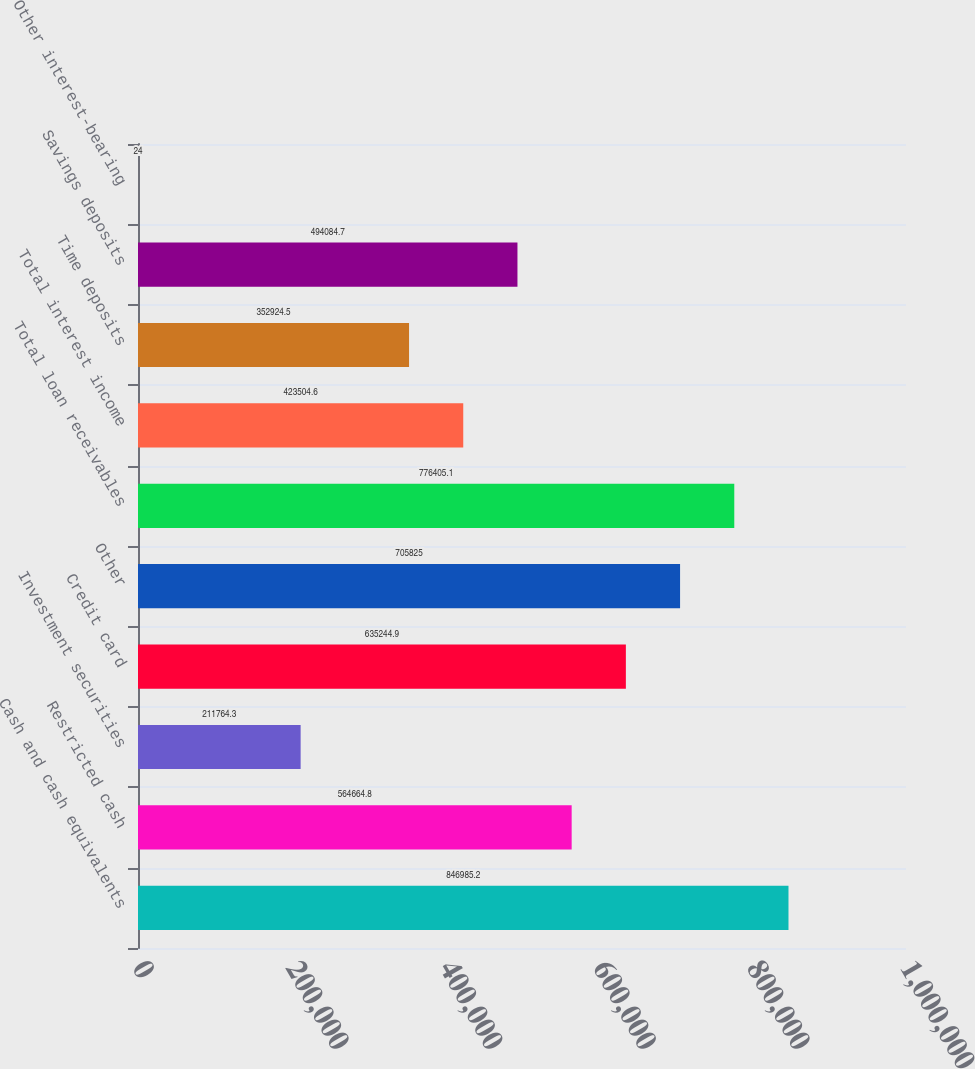<chart> <loc_0><loc_0><loc_500><loc_500><bar_chart><fcel>Cash and cash equivalents<fcel>Restricted cash<fcel>Investment securities<fcel>Credit card<fcel>Other<fcel>Total loan receivables<fcel>Total interest income<fcel>Time deposits<fcel>Savings deposits<fcel>Other interest-bearing<nl><fcel>846985<fcel>564665<fcel>211764<fcel>635245<fcel>705825<fcel>776405<fcel>423505<fcel>352924<fcel>494085<fcel>24<nl></chart> 